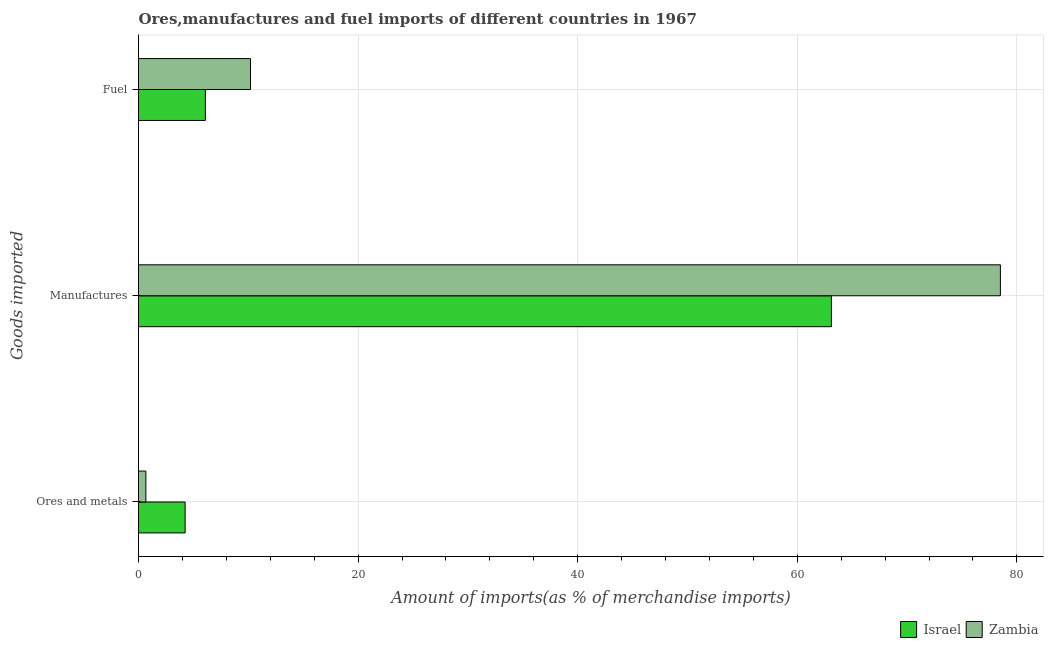How many different coloured bars are there?
Provide a short and direct response. 2. How many groups of bars are there?
Ensure brevity in your answer.  3. Are the number of bars per tick equal to the number of legend labels?
Offer a very short reply. Yes. How many bars are there on the 3rd tick from the top?
Keep it short and to the point. 2. How many bars are there on the 2nd tick from the bottom?
Offer a terse response. 2. What is the label of the 1st group of bars from the top?
Offer a terse response. Fuel. What is the percentage of fuel imports in Zambia?
Provide a succinct answer. 10.2. Across all countries, what is the maximum percentage of ores and metals imports?
Offer a terse response. 4.25. Across all countries, what is the minimum percentage of fuel imports?
Your answer should be very brief. 6.09. In which country was the percentage of manufactures imports maximum?
Offer a very short reply. Zambia. What is the total percentage of manufactures imports in the graph?
Provide a succinct answer. 141.61. What is the difference between the percentage of ores and metals imports in Israel and that in Zambia?
Ensure brevity in your answer.  3.58. What is the difference between the percentage of manufactures imports in Zambia and the percentage of ores and metals imports in Israel?
Offer a very short reply. 74.26. What is the average percentage of manufactures imports per country?
Provide a short and direct response. 70.81. What is the difference between the percentage of ores and metals imports and percentage of manufactures imports in Zambia?
Your answer should be compact. -77.83. What is the ratio of the percentage of ores and metals imports in Zambia to that in Israel?
Your response must be concise. 0.16. Is the percentage of fuel imports in Israel less than that in Zambia?
Your answer should be compact. Yes. What is the difference between the highest and the second highest percentage of manufactures imports?
Provide a short and direct response. 15.39. What is the difference between the highest and the lowest percentage of fuel imports?
Offer a very short reply. 4.11. Is the sum of the percentage of manufactures imports in Zambia and Israel greater than the maximum percentage of fuel imports across all countries?
Your answer should be compact. Yes. What does the 1st bar from the top in Manufactures represents?
Give a very brief answer. Zambia. What does the 1st bar from the bottom in Manufactures represents?
Your answer should be very brief. Israel. Is it the case that in every country, the sum of the percentage of ores and metals imports and percentage of manufactures imports is greater than the percentage of fuel imports?
Your answer should be compact. Yes. Are all the bars in the graph horizontal?
Give a very brief answer. Yes. How many countries are there in the graph?
Provide a short and direct response. 2. Are the values on the major ticks of X-axis written in scientific E-notation?
Keep it short and to the point. No. Does the graph contain any zero values?
Your answer should be compact. No. Where does the legend appear in the graph?
Make the answer very short. Bottom right. How many legend labels are there?
Offer a terse response. 2. How are the legend labels stacked?
Offer a very short reply. Horizontal. What is the title of the graph?
Your response must be concise. Ores,manufactures and fuel imports of different countries in 1967. Does "Sierra Leone" appear as one of the legend labels in the graph?
Give a very brief answer. No. What is the label or title of the X-axis?
Provide a short and direct response. Amount of imports(as % of merchandise imports). What is the label or title of the Y-axis?
Your answer should be compact. Goods imported. What is the Amount of imports(as % of merchandise imports) of Israel in Ores and metals?
Keep it short and to the point. 4.25. What is the Amount of imports(as % of merchandise imports) of Zambia in Ores and metals?
Offer a terse response. 0.67. What is the Amount of imports(as % of merchandise imports) in Israel in Manufactures?
Your response must be concise. 63.11. What is the Amount of imports(as % of merchandise imports) of Zambia in Manufactures?
Provide a short and direct response. 78.5. What is the Amount of imports(as % of merchandise imports) in Israel in Fuel?
Your answer should be compact. 6.09. What is the Amount of imports(as % of merchandise imports) of Zambia in Fuel?
Ensure brevity in your answer.  10.2. Across all Goods imported, what is the maximum Amount of imports(as % of merchandise imports) in Israel?
Your answer should be very brief. 63.11. Across all Goods imported, what is the maximum Amount of imports(as % of merchandise imports) of Zambia?
Your response must be concise. 78.5. Across all Goods imported, what is the minimum Amount of imports(as % of merchandise imports) of Israel?
Offer a very short reply. 4.25. Across all Goods imported, what is the minimum Amount of imports(as % of merchandise imports) of Zambia?
Provide a short and direct response. 0.67. What is the total Amount of imports(as % of merchandise imports) in Israel in the graph?
Provide a short and direct response. 73.45. What is the total Amount of imports(as % of merchandise imports) in Zambia in the graph?
Provide a succinct answer. 89.37. What is the difference between the Amount of imports(as % of merchandise imports) in Israel in Ores and metals and that in Manufactures?
Your answer should be compact. -58.86. What is the difference between the Amount of imports(as % of merchandise imports) of Zambia in Ores and metals and that in Manufactures?
Keep it short and to the point. -77.83. What is the difference between the Amount of imports(as % of merchandise imports) in Israel in Ores and metals and that in Fuel?
Make the answer very short. -1.85. What is the difference between the Amount of imports(as % of merchandise imports) of Zambia in Ores and metals and that in Fuel?
Give a very brief answer. -9.53. What is the difference between the Amount of imports(as % of merchandise imports) in Israel in Manufactures and that in Fuel?
Give a very brief answer. 57.02. What is the difference between the Amount of imports(as % of merchandise imports) of Zambia in Manufactures and that in Fuel?
Your response must be concise. 68.3. What is the difference between the Amount of imports(as % of merchandise imports) in Israel in Ores and metals and the Amount of imports(as % of merchandise imports) in Zambia in Manufactures?
Provide a short and direct response. -74.26. What is the difference between the Amount of imports(as % of merchandise imports) of Israel in Ores and metals and the Amount of imports(as % of merchandise imports) of Zambia in Fuel?
Provide a succinct answer. -5.95. What is the difference between the Amount of imports(as % of merchandise imports) in Israel in Manufactures and the Amount of imports(as % of merchandise imports) in Zambia in Fuel?
Keep it short and to the point. 52.91. What is the average Amount of imports(as % of merchandise imports) in Israel per Goods imported?
Give a very brief answer. 24.48. What is the average Amount of imports(as % of merchandise imports) in Zambia per Goods imported?
Make the answer very short. 29.79. What is the difference between the Amount of imports(as % of merchandise imports) in Israel and Amount of imports(as % of merchandise imports) in Zambia in Ores and metals?
Your response must be concise. 3.58. What is the difference between the Amount of imports(as % of merchandise imports) in Israel and Amount of imports(as % of merchandise imports) in Zambia in Manufactures?
Provide a succinct answer. -15.39. What is the difference between the Amount of imports(as % of merchandise imports) of Israel and Amount of imports(as % of merchandise imports) of Zambia in Fuel?
Your answer should be very brief. -4.11. What is the ratio of the Amount of imports(as % of merchandise imports) in Israel in Ores and metals to that in Manufactures?
Offer a very short reply. 0.07. What is the ratio of the Amount of imports(as % of merchandise imports) in Zambia in Ores and metals to that in Manufactures?
Ensure brevity in your answer.  0.01. What is the ratio of the Amount of imports(as % of merchandise imports) of Israel in Ores and metals to that in Fuel?
Your answer should be very brief. 0.7. What is the ratio of the Amount of imports(as % of merchandise imports) in Zambia in Ores and metals to that in Fuel?
Your answer should be compact. 0.07. What is the ratio of the Amount of imports(as % of merchandise imports) in Israel in Manufactures to that in Fuel?
Your answer should be very brief. 10.36. What is the ratio of the Amount of imports(as % of merchandise imports) in Zambia in Manufactures to that in Fuel?
Give a very brief answer. 7.7. What is the difference between the highest and the second highest Amount of imports(as % of merchandise imports) in Israel?
Provide a succinct answer. 57.02. What is the difference between the highest and the second highest Amount of imports(as % of merchandise imports) of Zambia?
Offer a terse response. 68.3. What is the difference between the highest and the lowest Amount of imports(as % of merchandise imports) in Israel?
Provide a succinct answer. 58.86. What is the difference between the highest and the lowest Amount of imports(as % of merchandise imports) of Zambia?
Provide a short and direct response. 77.83. 